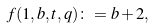<formula> <loc_0><loc_0><loc_500><loc_500>f ( 1 , b , t , q ) \colon = b + 2 ,</formula> 